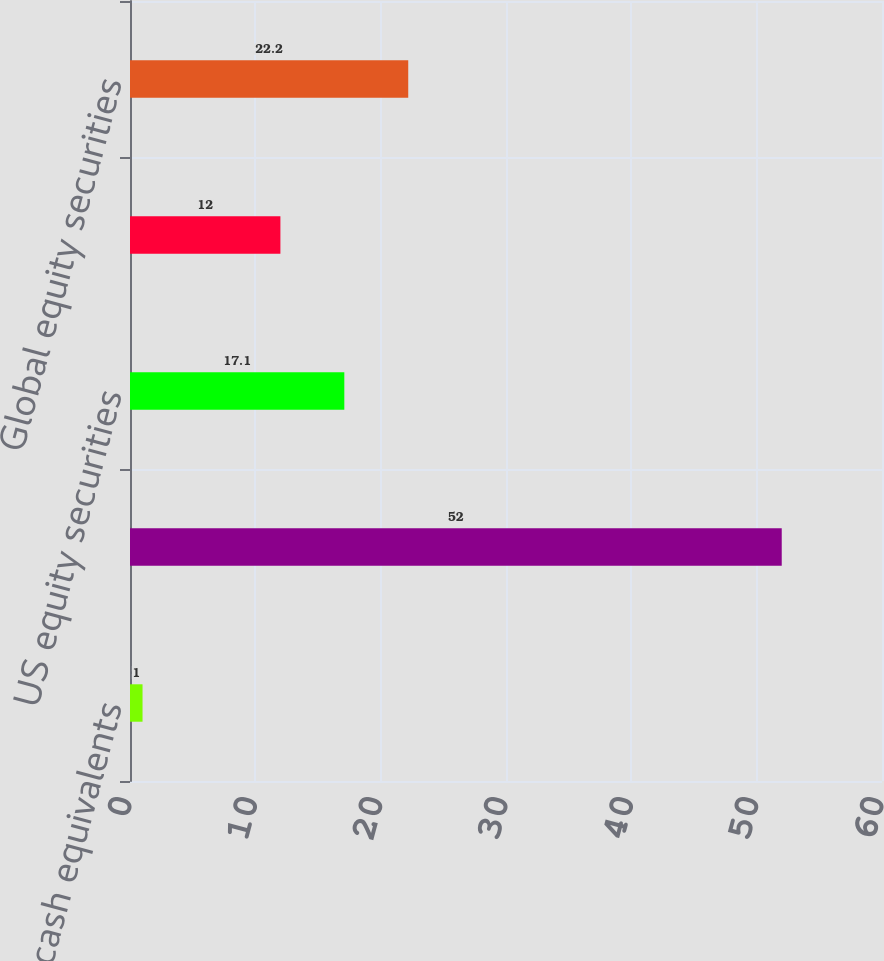Convert chart to OTSL. <chart><loc_0><loc_0><loc_500><loc_500><bar_chart><fcel>Cash and cash equivalents<fcel>Fixed income securities<fcel>US equity securities<fcel>International equity<fcel>Global equity securities<nl><fcel>1<fcel>52<fcel>17.1<fcel>12<fcel>22.2<nl></chart> 